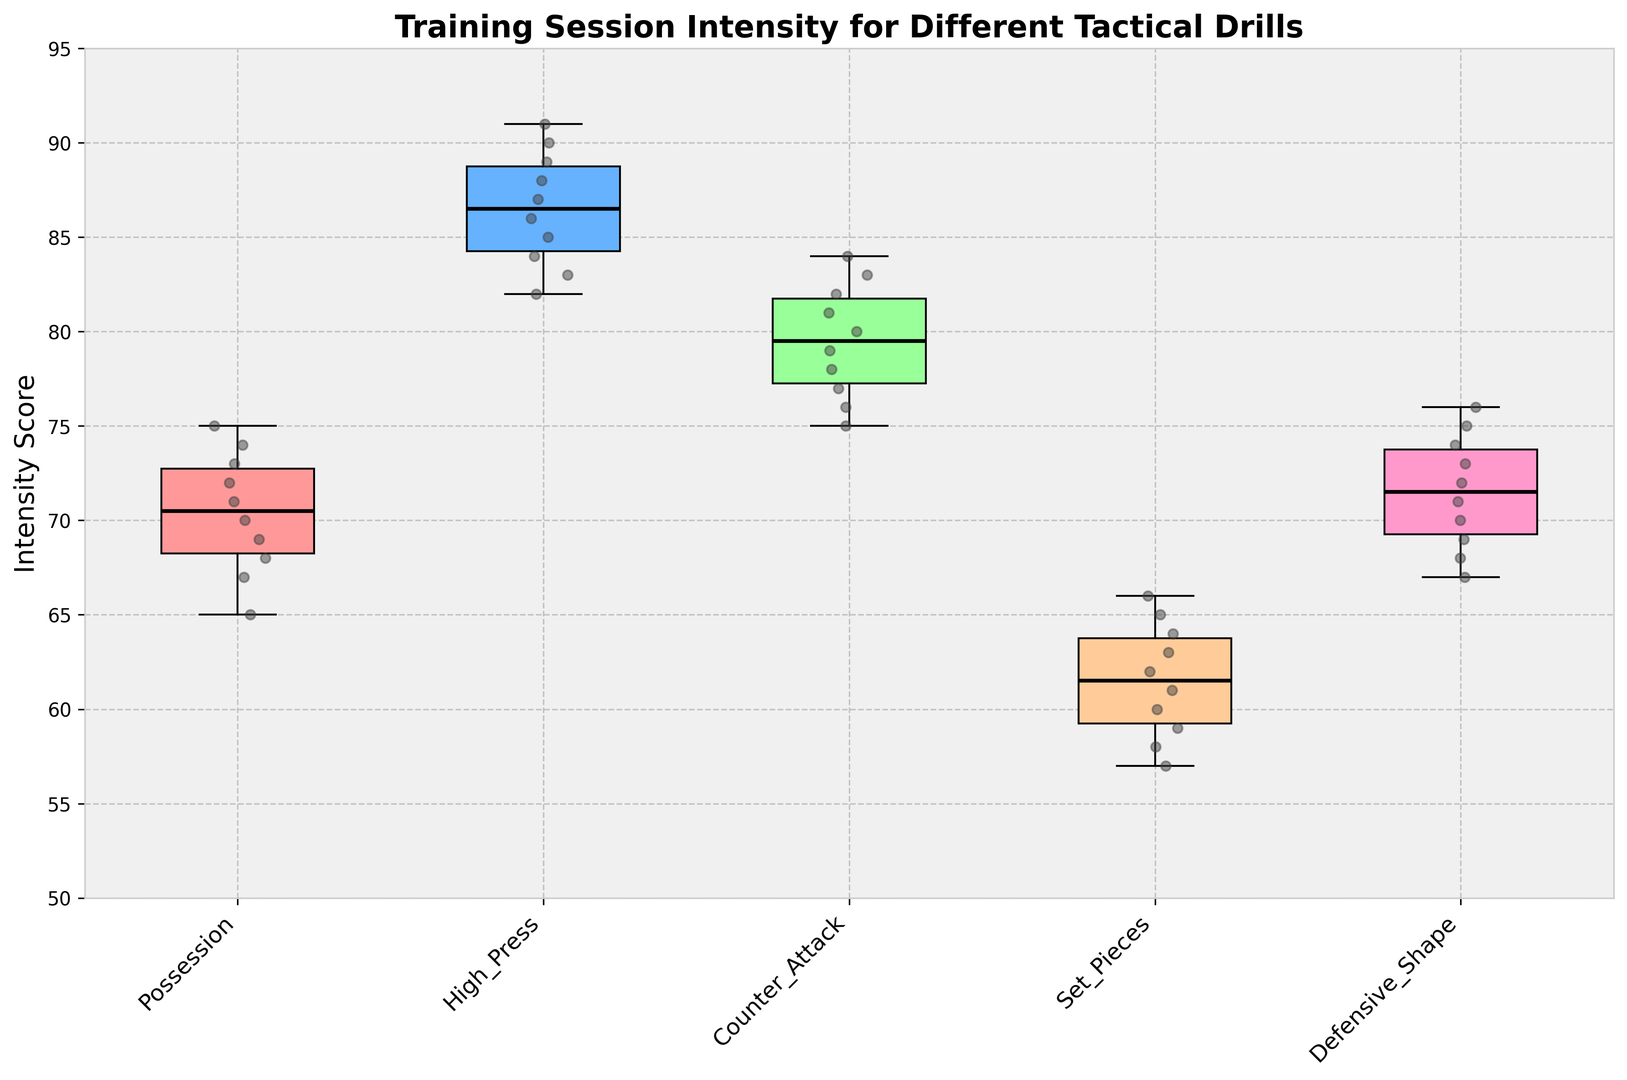What's the median intensity score for the 'High_Press' drill? Locate the 'High_Press' box plot, identify the median line within the box. The median is marked by the black line in the middle of the box.
Answer: 87 Which drill has the highest median intensity score? Compare the median lines (black lines within the boxes) of all the drills, the highest median will be the one with the top-most position of its black line.
Answer: High_Press How does the median intensity score of the 'Defensive_Shape' drill compare to the 'Possession' drill? Locate the median lines in the boxes for 'Defensive_Shape' and 'Possession'. Compare their positions: 'Defensive_Shape' has a median line slightly higher than 'Possession', indicating a higher median score.
Answer: Defensive_Shape is higher What is the interquartile range (IQR) of intensity scores for the 'Set_Pieces' drill? Identify the edges of the box for 'Set_Pieces', the bottom edge represents Q1 (25th percentile) which is 59, and the top edge is Q3 (75th percentile) which is 64. The IQR is Q3 - Q1.
Answer: 5 Which drill has the smallest range of intensity scores? Range is the difference between the maximum and minimum scores for each drill. Compare the length of the whiskers (the lines extending from the boxes). The smallest range will have the shortest whiskers.
Answer: Set_Pieces For the 'Counter_Attack' drill, what is the maximum intensity score? Look at the top whisker of the 'Counter_Attack' box plot, the line at the end of the top whisker represents the maximum score.
Answer: 84 Are there any outliers in the intensity scores for 'Possession'? Typically, outliers are represented by individual points outside the whiskers of the box plot. Check if there are any points significantly detached from the whiskers of the 'Possession' box.
Answer: No Compare the range of intensity scores between 'High_Press' and 'Defensive_Shape'. Calculate the distance between the top and bottom whiskers for 'High_Press' and 'Defensive_Shape'. The visual length of these segments indicates their respective ranges.
Answer: High_Press has a bigger range Which drill has the longest interquartile range (IQR) of intensity scores? Look at the height of the boxes, which represents the IQR (Q3 - Q1). The tallest box indicates the longest IQR.
Answer: High_Press 